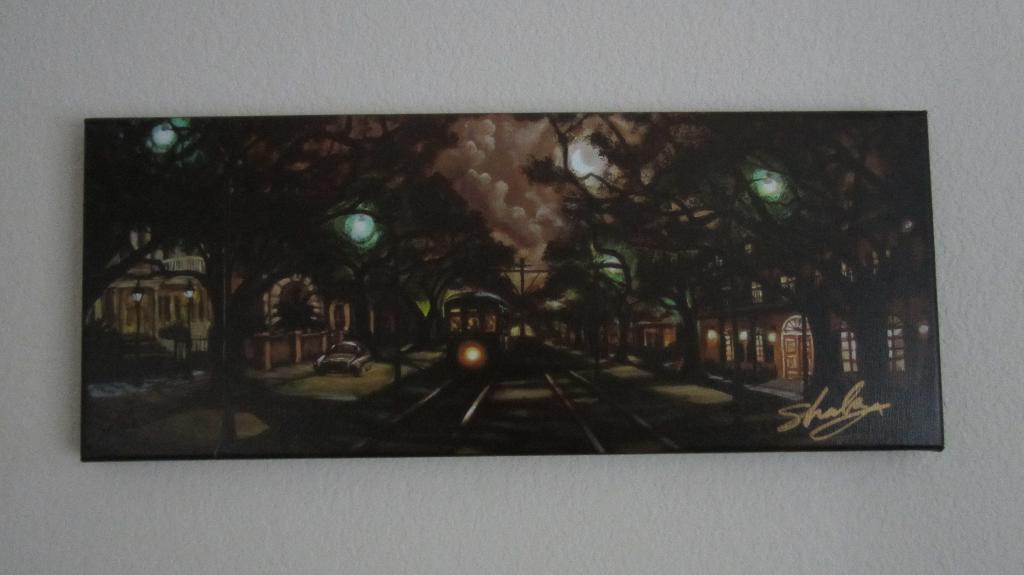Provide a one-sentence caption for the provided image. Painting showing a dark night and a signature that says Shala. 